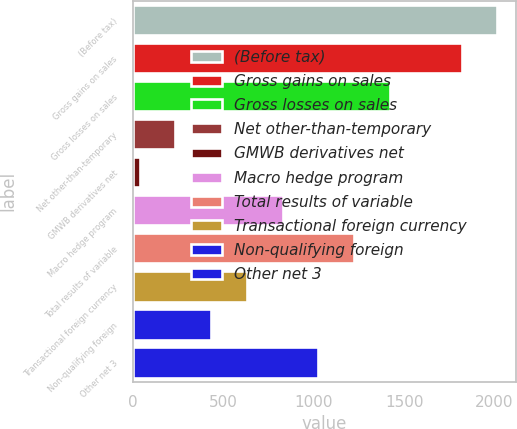<chart> <loc_0><loc_0><loc_500><loc_500><bar_chart><fcel>(Before tax)<fcel>Gross gains on sales<fcel>Gross losses on sales<fcel>Net other-than-temporary<fcel>GMWB derivatives net<fcel>Macro hedge program<fcel>Total results of variable<fcel>Transactional foreign currency<fcel>Non-qualifying foreign<fcel>Other net 3<nl><fcel>2016<fcel>1818.2<fcel>1422.6<fcel>235.8<fcel>38<fcel>829.2<fcel>1224.8<fcel>631.4<fcel>433.6<fcel>1027<nl></chart> 